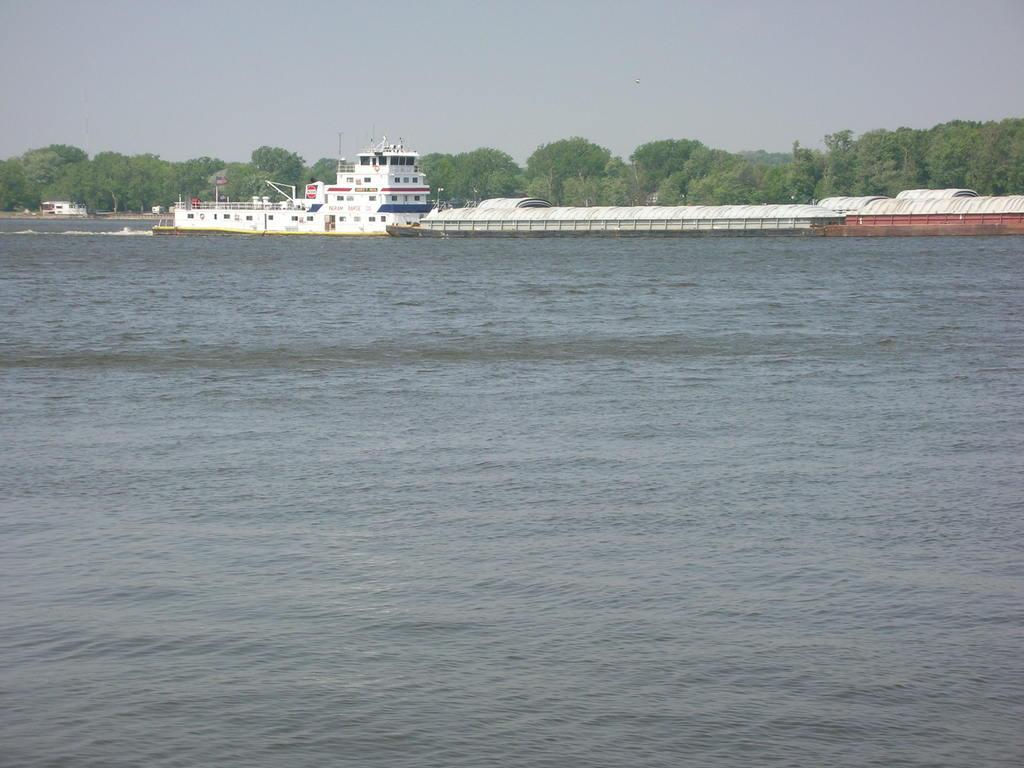What is in the foreground of the image? There is a water body in the foreground of the image. What can be seen in the center of the image? There are ships and trees in the center of the image. What is the condition of the sky in the image? The sky is cloudy in the image. What word is being shouted by the people on the ships in the image? There are no people shouting any words on the ships in the image; the ships are stationary in the water. How does the alarm sound in the image? There is no alarm present in the image. 